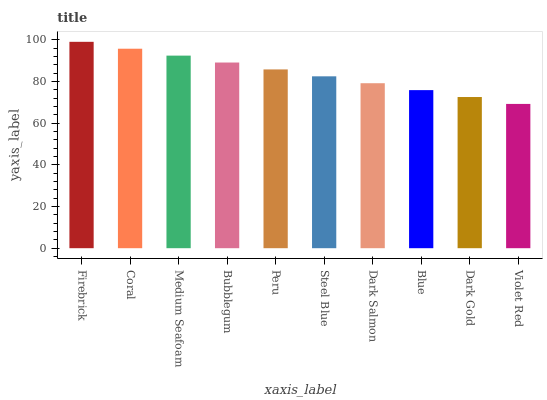Is Violet Red the minimum?
Answer yes or no. Yes. Is Firebrick the maximum?
Answer yes or no. Yes. Is Coral the minimum?
Answer yes or no. No. Is Coral the maximum?
Answer yes or no. No. Is Firebrick greater than Coral?
Answer yes or no. Yes. Is Coral less than Firebrick?
Answer yes or no. Yes. Is Coral greater than Firebrick?
Answer yes or no. No. Is Firebrick less than Coral?
Answer yes or no. No. Is Peru the high median?
Answer yes or no. Yes. Is Steel Blue the low median?
Answer yes or no. Yes. Is Violet Red the high median?
Answer yes or no. No. Is Dark Gold the low median?
Answer yes or no. No. 